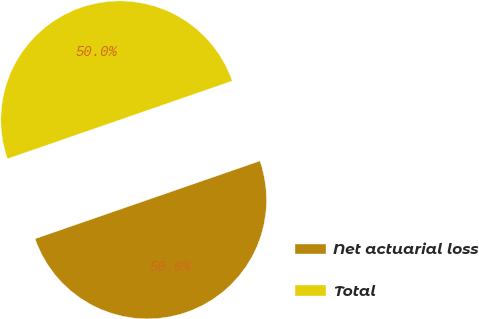Convert chart. <chart><loc_0><loc_0><loc_500><loc_500><pie_chart><fcel>Net actuarial loss<fcel>Total<nl><fcel>50.0%<fcel>50.0%<nl></chart> 